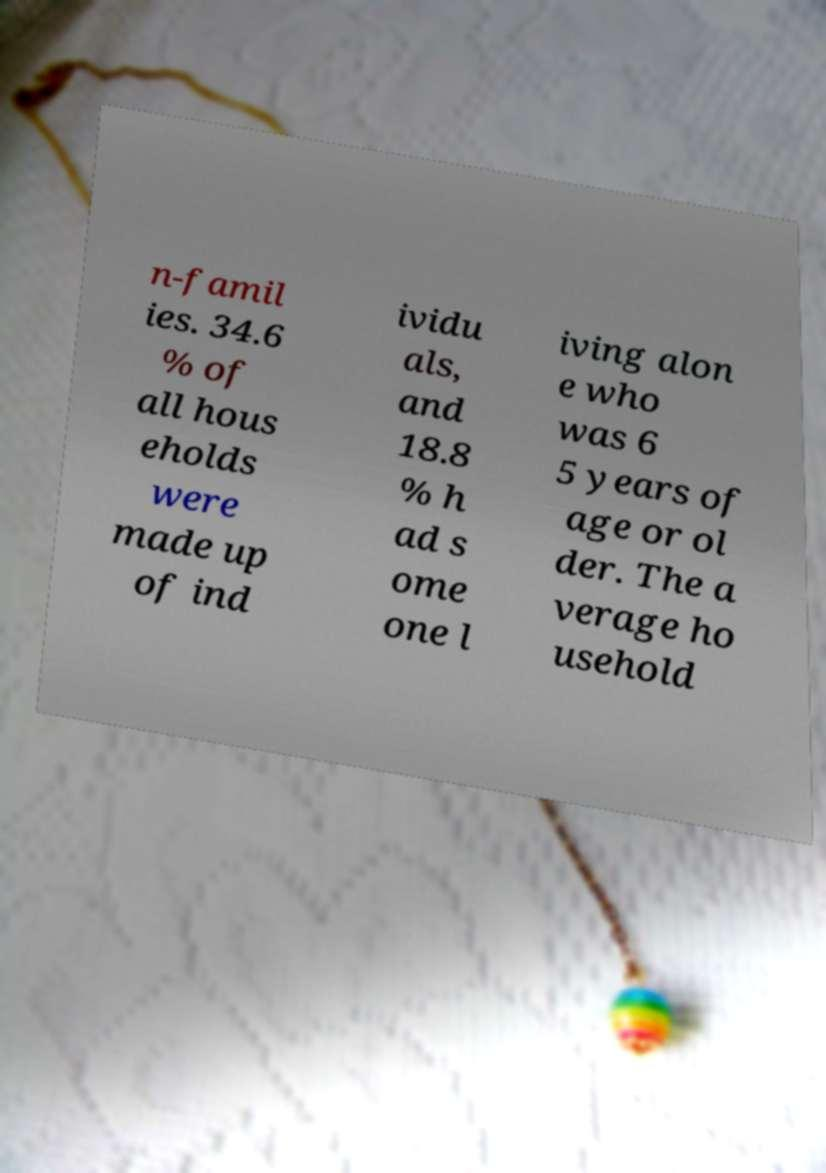Could you assist in decoding the text presented in this image and type it out clearly? n-famil ies. 34.6 % of all hous eholds were made up of ind ividu als, and 18.8 % h ad s ome one l iving alon e who was 6 5 years of age or ol der. The a verage ho usehold 